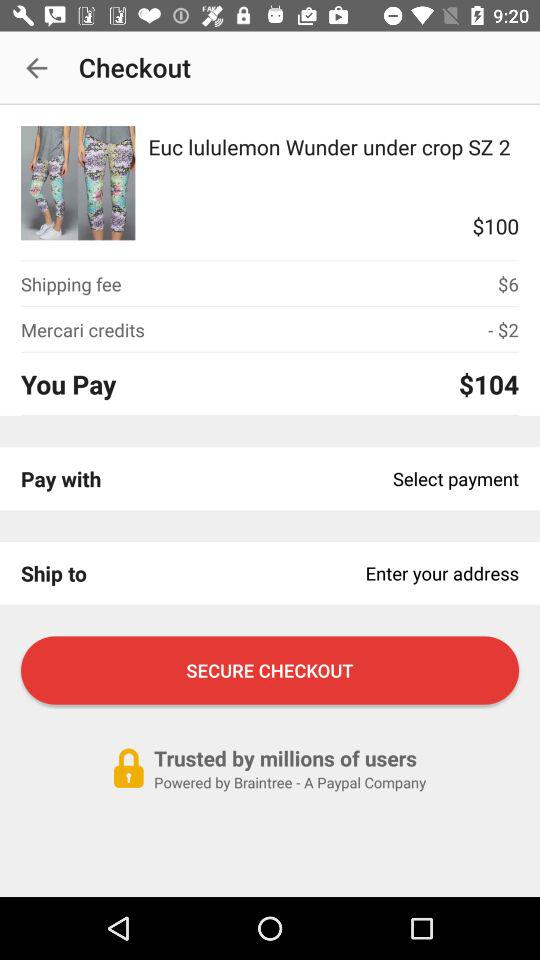What is the shipping fee? The shipping fee is $6. 